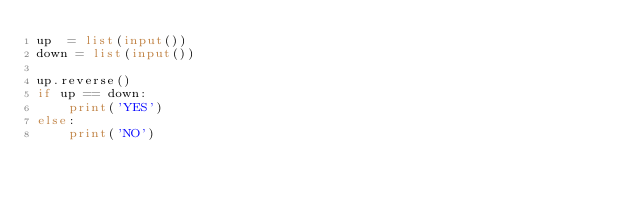<code> <loc_0><loc_0><loc_500><loc_500><_Python_>up  = list(input())
down = list(input())

up.reverse()
if up == down:
    print('YES')
else:
    print('NO')

</code> 